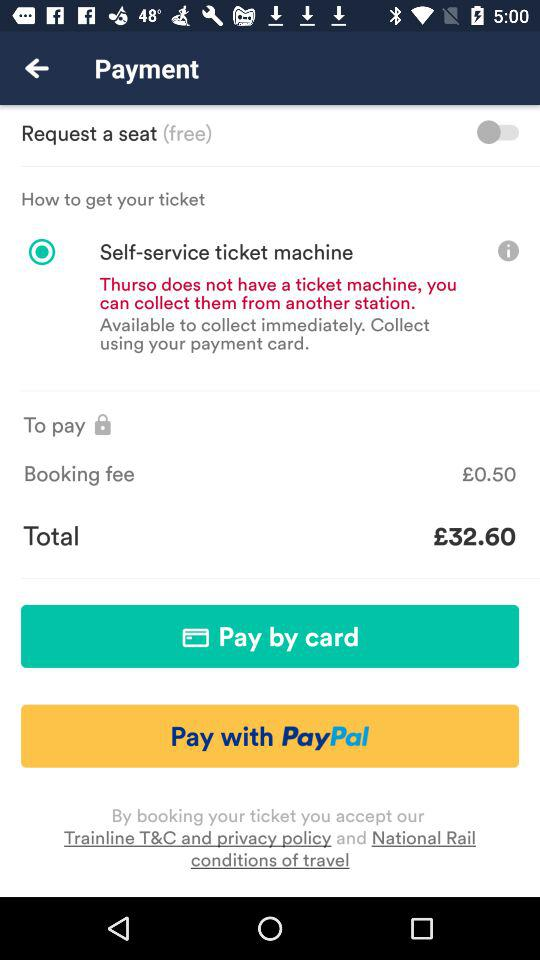What are the payment options? The payment options are "Pay by card" and "Pay with PayPal". 